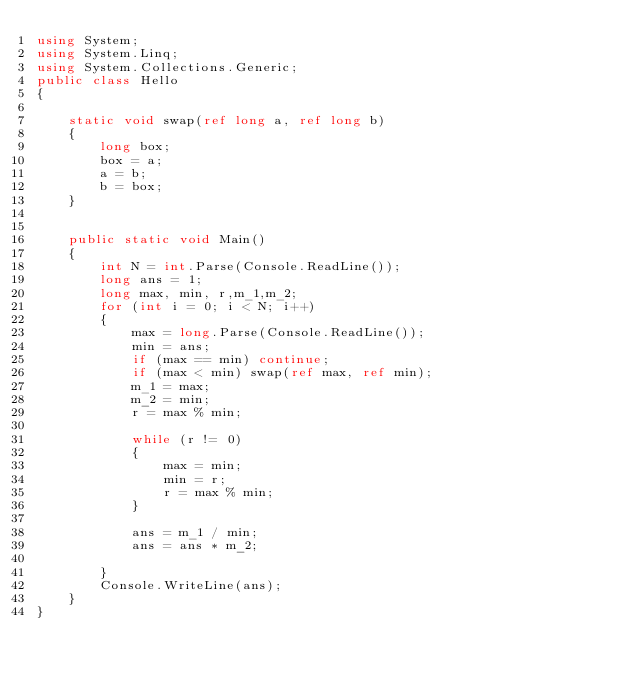Convert code to text. <code><loc_0><loc_0><loc_500><loc_500><_C#_>using System;
using System.Linq;
using System.Collections.Generic;
public class Hello
{

    static void swap(ref long a, ref long b)
    {
        long box;
        box = a;
        a = b;
        b = box;
    }


    public static void Main()
    {
        int N = int.Parse(Console.ReadLine());
        long ans = 1;
        long max, min, r,m_1,m_2;
        for (int i = 0; i < N; i++)
        {
            max = long.Parse(Console.ReadLine());
            min = ans;
            if (max == min) continue;
            if (max < min) swap(ref max, ref min);
            m_1 = max;
            m_2 = min;
            r = max % min;

            while (r != 0)
            {
                max = min;
                min = r;
                r = max % min;
            }

            ans = m_1 / min;
            ans = ans * m_2;

        }
        Console.WriteLine(ans);
    }
}</code> 